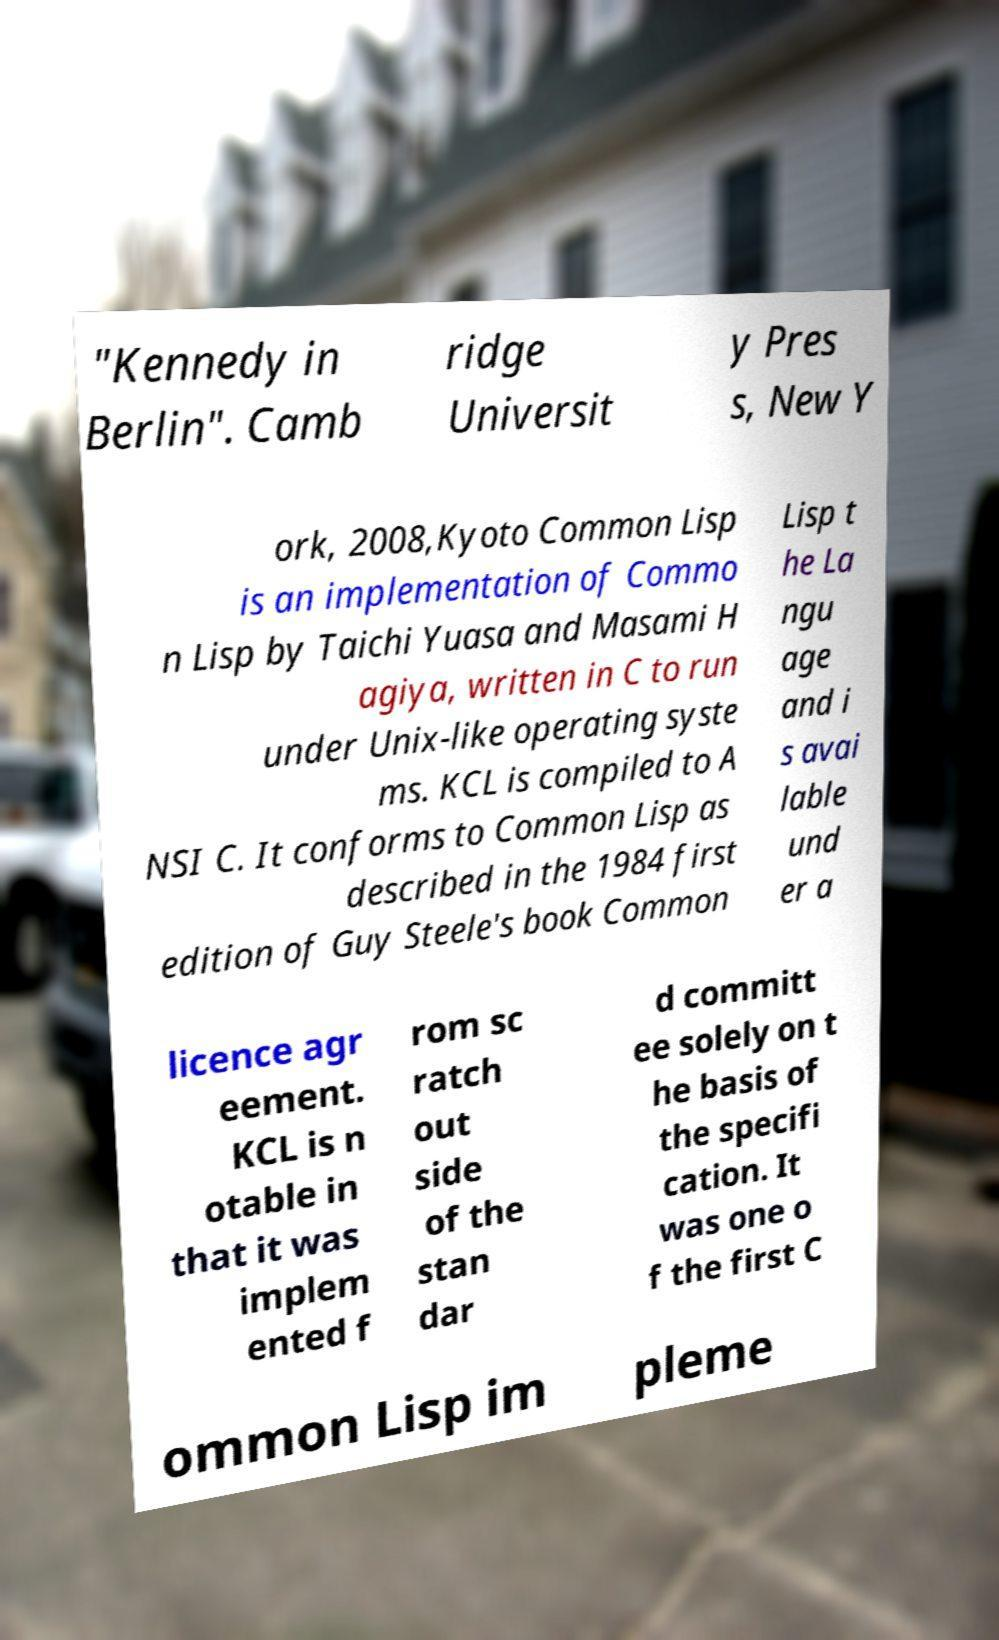I need the written content from this picture converted into text. Can you do that? "Kennedy in Berlin". Camb ridge Universit y Pres s, New Y ork, 2008,Kyoto Common Lisp is an implementation of Commo n Lisp by Taichi Yuasa and Masami H agiya, written in C to run under Unix-like operating syste ms. KCL is compiled to A NSI C. It conforms to Common Lisp as described in the 1984 first edition of Guy Steele's book Common Lisp t he La ngu age and i s avai lable und er a licence agr eement. KCL is n otable in that it was implem ented f rom sc ratch out side of the stan dar d committ ee solely on t he basis of the specifi cation. It was one o f the first C ommon Lisp im pleme 